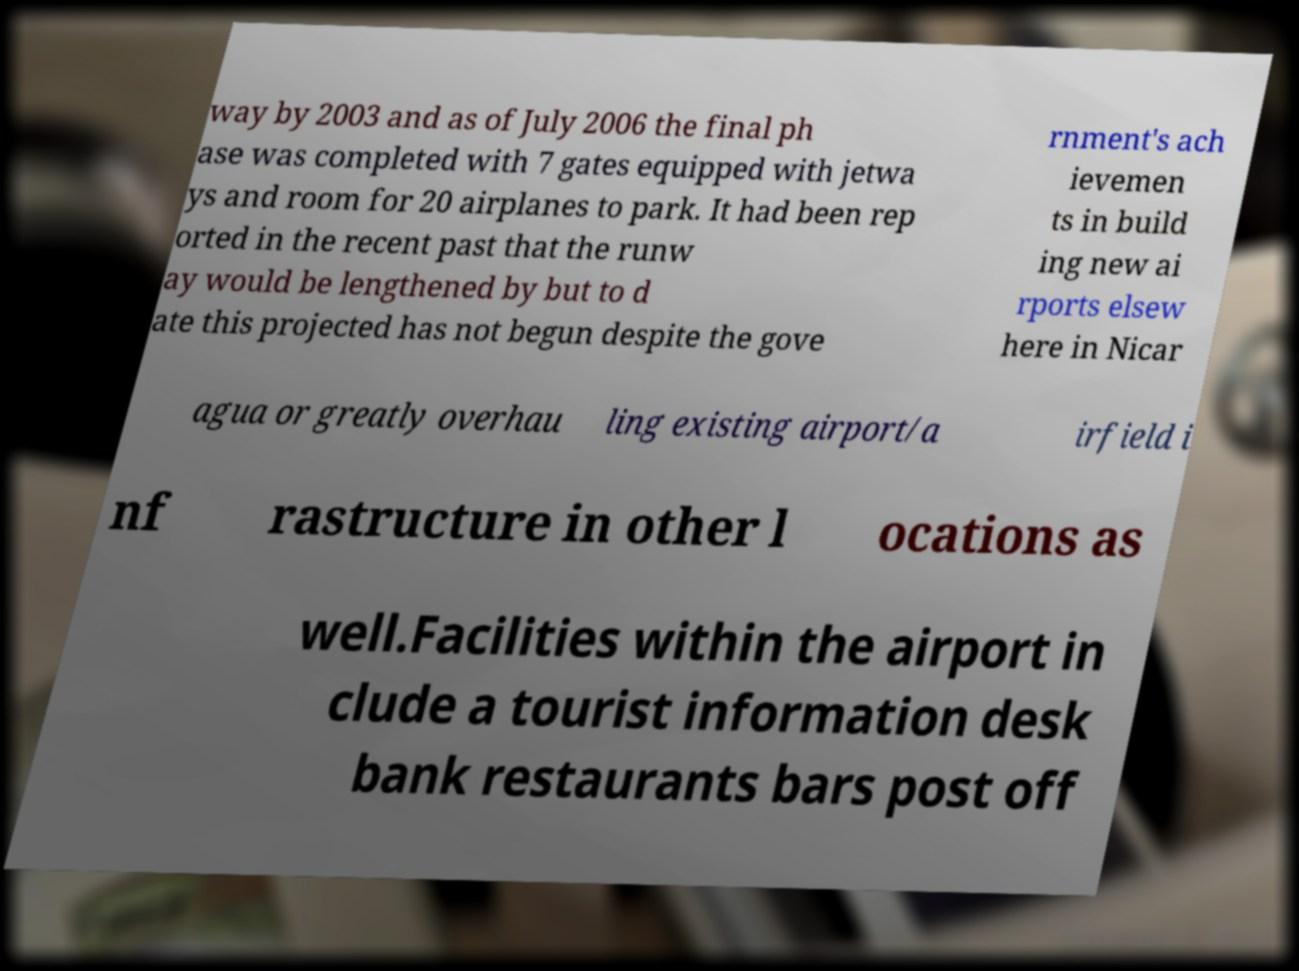For documentation purposes, I need the text within this image transcribed. Could you provide that? way by 2003 and as of July 2006 the final ph ase was completed with 7 gates equipped with jetwa ys and room for 20 airplanes to park. It had been rep orted in the recent past that the runw ay would be lengthened by but to d ate this projected has not begun despite the gove rnment's ach ievemen ts in build ing new ai rports elsew here in Nicar agua or greatly overhau ling existing airport/a irfield i nf rastructure in other l ocations as well.Facilities within the airport in clude a tourist information desk bank restaurants bars post off 